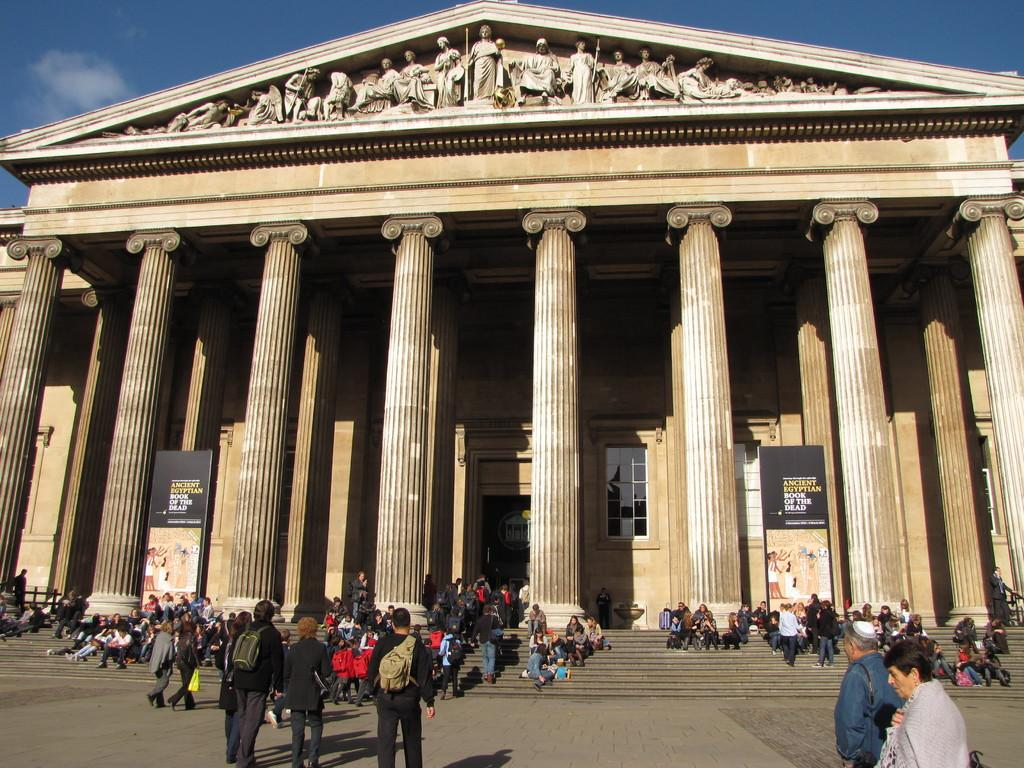<image>
Render a clear and concise summary of the photo. a columned building with signs for Ancient Egyptian Book of the Dead 